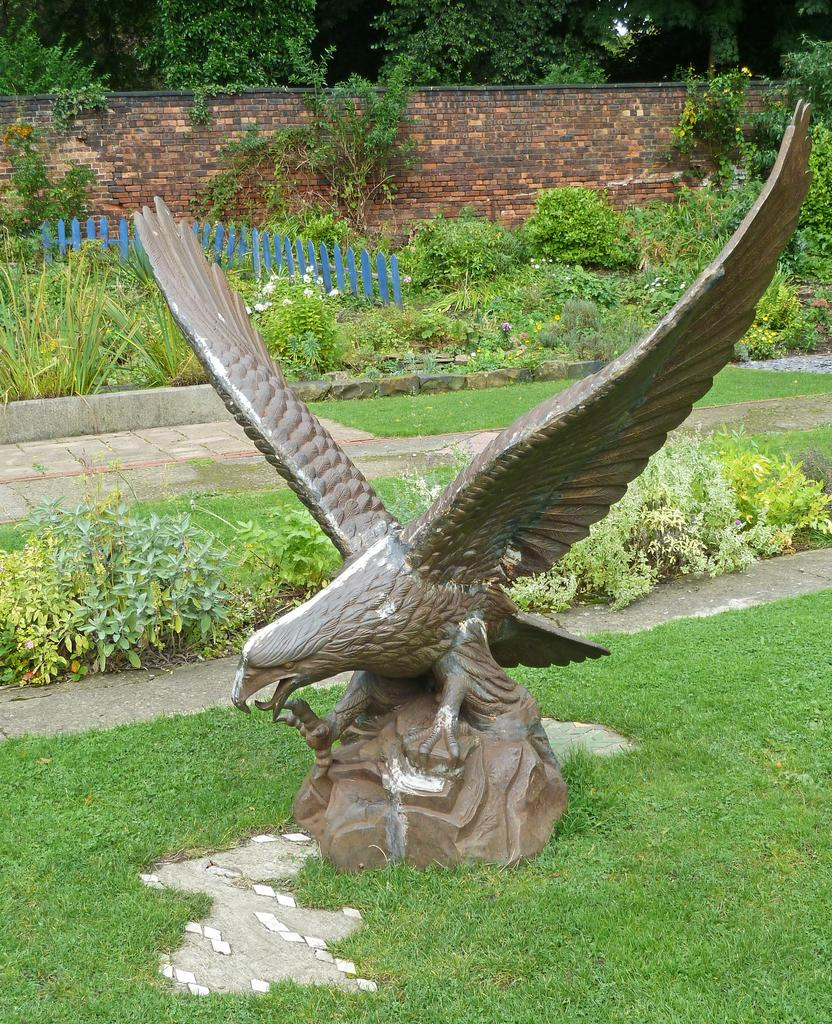What is the main subject of the sculpture in the image? The sculpture in the image is of a bird. What type of natural environment is depicted in the image? There is grass, plants, and trees in the background of the image. What structures are present in the image? There is a fence and a wall in the image. What type of toy can be seen playing with dust in the image? There is no toy or dust present in the image. What hobbies are the plants in the image pursuing? Plants do not have hobbies, as they are living organisms and not sentient beings. 